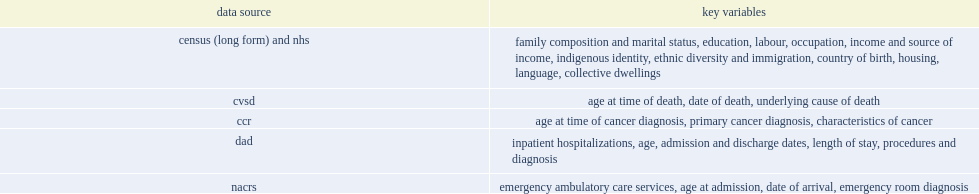What were the key variables of census (long form) and nhs. Family composition and marital status, education, labour, occupation, income and source of income, indigenous identity, ethnic diversity and immigration, country of birth, housing, language, collective dwellings. 